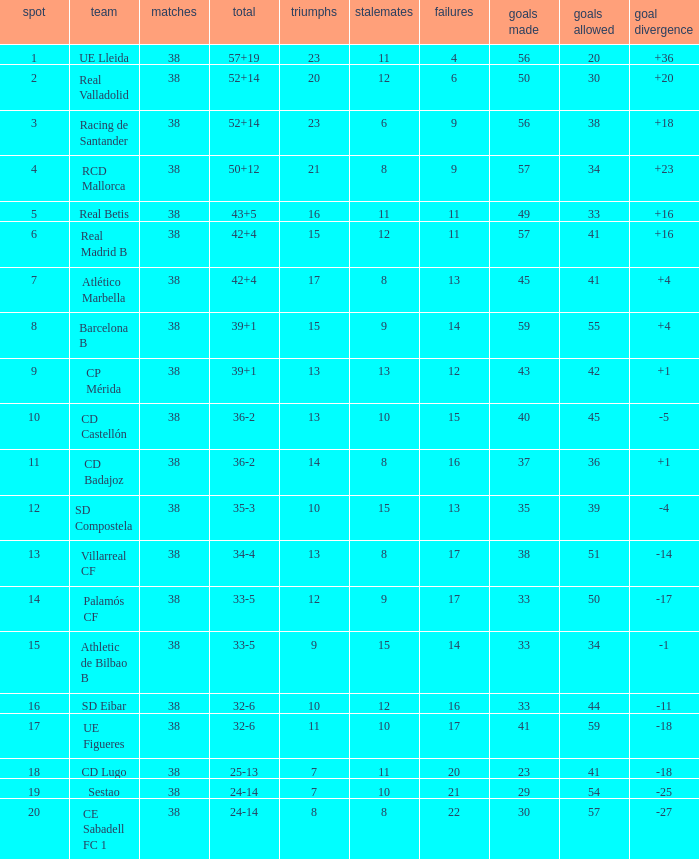What is the highest number of wins with a goal difference less than 4 at the Villarreal CF and more than 38 played? None. 